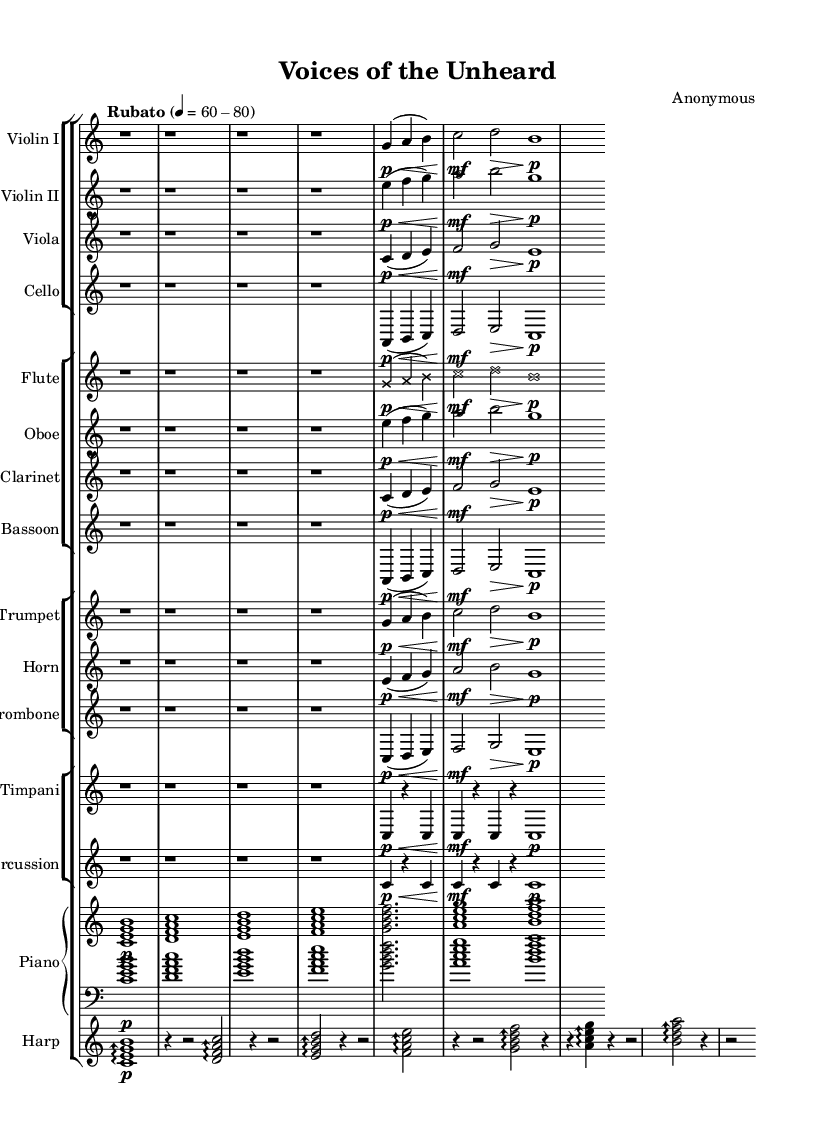What is the time signature of this music? The time signature is indicated at the beginning of the music with "4/4" for most measures, and there's also a shift to "3/4" during various sections. This suggests that the piece alternates between these two time signatures.
Answer: 4/4 and 3/4 What is the tempo marking for this piece? The tempo marking is labeled as "Rubato" with a speed of "4 = 60-80". This indicates that the piece should be played with flexibility in tempo.
Answer: Rubato How many different instrument groups are present in this orchestral piece? Upon examining the score, there are four distinct groups: strings, woodwinds, brass, and percussion. Each group has specific instruments associated with it, which can be counted directly.
Answer: Four Which instrument plays the lowest pitch in this piece? The cello section is typically the lowest in pitch among the string instruments, and in this context, it is the only instrument listed that plays the lowest notes compared to the others used throughout the piece.
Answer: Cello Describe the dynamic markings of the flute section. The flute part has a dynamic marking of "p" (piano) followed by a ">" (crescendo) at the start, indicating soft playing that gradually increases in volume. This showcases the expressive qualities aimed to reflect emotional nuances.
Answer: Piano and crescendo In how many measures does the timpani have a note? Timpani notes are prominent in measures labeled with "3/4" and "4/4," and by counting the relevant sections, there are six measures with active timpani parts.
Answer: Six What is the role of the harp in this composition? The harp is indicated to play arpeggiated chords in a lyrical style throughout the piece, which adds texture and an ethereal quality to the overall sound, aligning well with the avant-garde experimental nature of the work.
Answer: Arpeggiated chords 